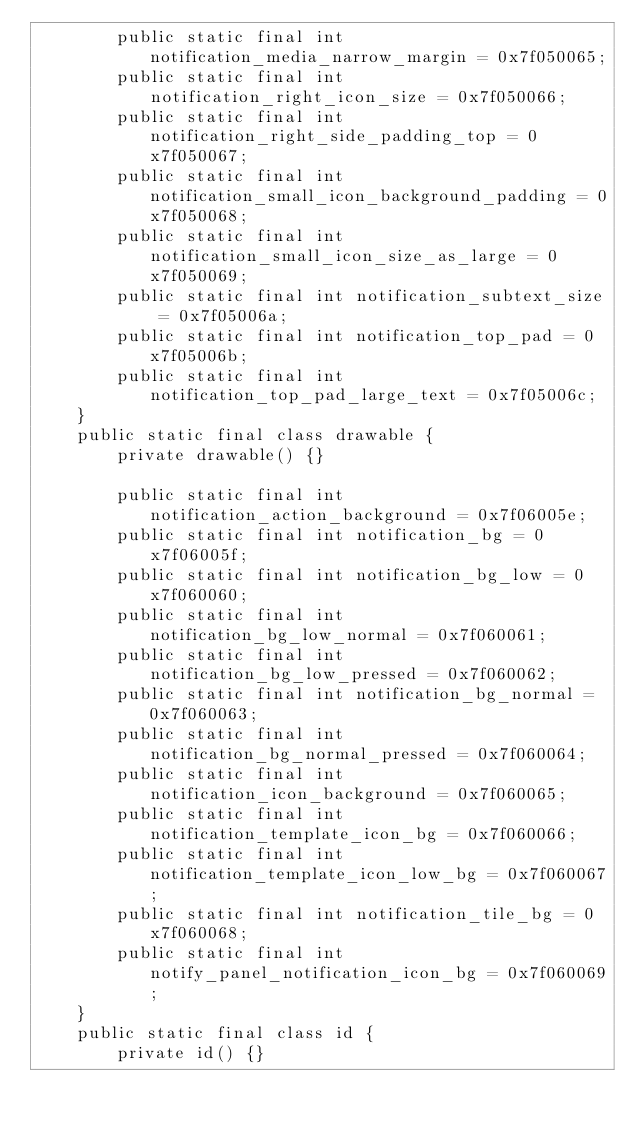<code> <loc_0><loc_0><loc_500><loc_500><_Java_>        public static final int notification_media_narrow_margin = 0x7f050065;
        public static final int notification_right_icon_size = 0x7f050066;
        public static final int notification_right_side_padding_top = 0x7f050067;
        public static final int notification_small_icon_background_padding = 0x7f050068;
        public static final int notification_small_icon_size_as_large = 0x7f050069;
        public static final int notification_subtext_size = 0x7f05006a;
        public static final int notification_top_pad = 0x7f05006b;
        public static final int notification_top_pad_large_text = 0x7f05006c;
    }
    public static final class drawable {
        private drawable() {}

        public static final int notification_action_background = 0x7f06005e;
        public static final int notification_bg = 0x7f06005f;
        public static final int notification_bg_low = 0x7f060060;
        public static final int notification_bg_low_normal = 0x7f060061;
        public static final int notification_bg_low_pressed = 0x7f060062;
        public static final int notification_bg_normal = 0x7f060063;
        public static final int notification_bg_normal_pressed = 0x7f060064;
        public static final int notification_icon_background = 0x7f060065;
        public static final int notification_template_icon_bg = 0x7f060066;
        public static final int notification_template_icon_low_bg = 0x7f060067;
        public static final int notification_tile_bg = 0x7f060068;
        public static final int notify_panel_notification_icon_bg = 0x7f060069;
    }
    public static final class id {
        private id() {}
</code> 